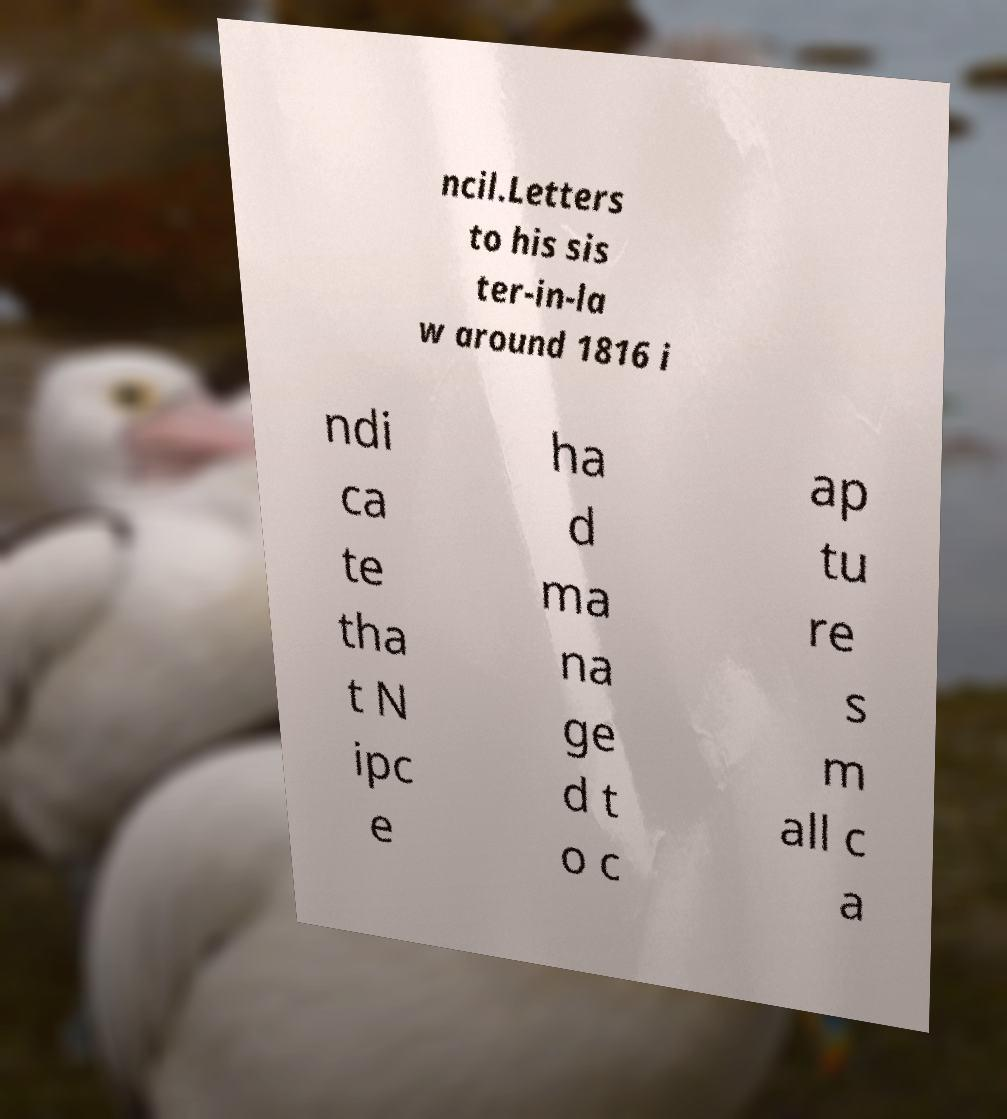Please identify and transcribe the text found in this image. ncil.Letters to his sis ter-in-la w around 1816 i ndi ca te tha t N ipc e ha d ma na ge d t o c ap tu re s m all c a 